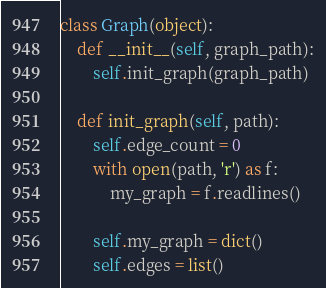<code> <loc_0><loc_0><loc_500><loc_500><_Python_>class Graph(object):
    def __init__(self, graph_path):
        self.init_graph(graph_path)

    def init_graph(self, path):
        self.edge_count = 0
        with open(path, 'r') as f:
            my_graph = f.readlines()

        self.my_graph = dict()
        self.edges = list()</code> 